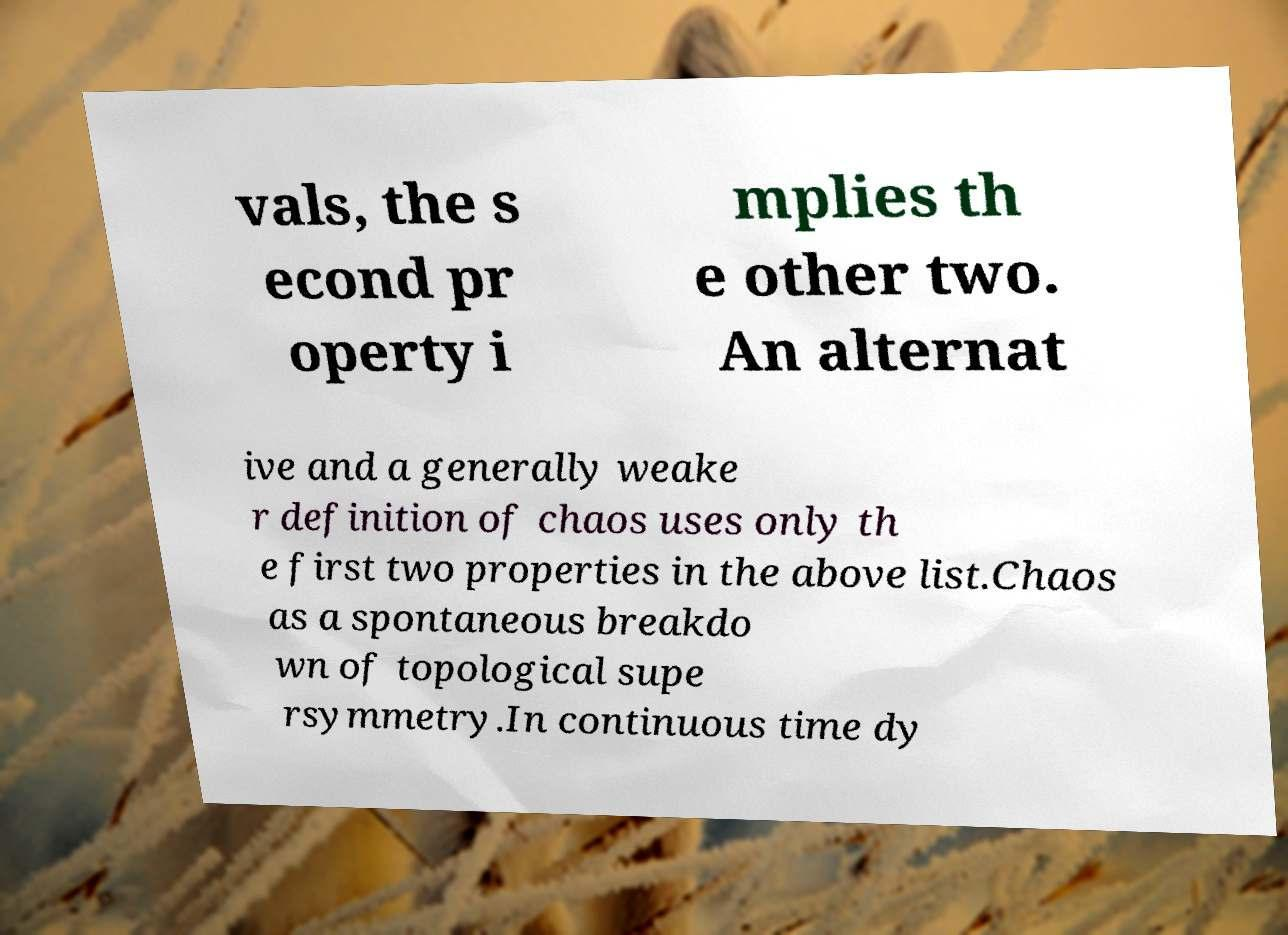Please identify and transcribe the text found in this image. vals, the s econd pr operty i mplies th e other two. An alternat ive and a generally weake r definition of chaos uses only th e first two properties in the above list.Chaos as a spontaneous breakdo wn of topological supe rsymmetry.In continuous time dy 